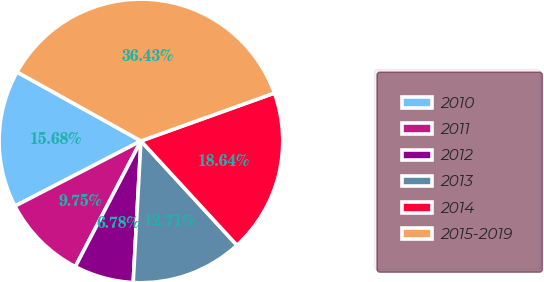Convert chart to OTSL. <chart><loc_0><loc_0><loc_500><loc_500><pie_chart><fcel>2010<fcel>2011<fcel>2012<fcel>2013<fcel>2014<fcel>2015-2019<nl><fcel>15.68%<fcel>9.75%<fcel>6.78%<fcel>12.71%<fcel>18.64%<fcel>36.43%<nl></chart> 